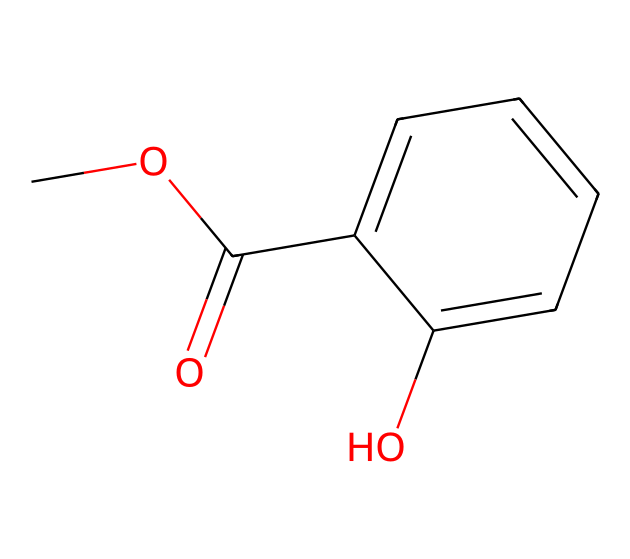What is the molecular formula of methyl salicylate? The SMILES representation shows the structure of methyl salicylate, from which we can derive the molecular formula by counting the atoms. There are 9 carbon atoms (C), 10 hydrogen atoms (H), and 3 oxygen atoms (O) indicated by the structure of the chemical. This gives us a molecular formula of C9H10O3.
Answer: C9H10O3 How many rings are present in the structure of this ester? By examining the structure represented by the SMILES, we can identify the presence of a ring. The part C1=CC=CC=C1 shows a benzene ring, which is a six-membered carbon ring. There are no additional rings present in the structure.
Answer: 1 What functional groups are found in methyl salicylate? The SMILES indicates two functional groups: one is the ester group represented by COC(=O), and the other is the hydroxyl group (–OH) shown at the end of the phenolic part of the structure. These groups contribute to the unique properties of methyl salicylate.
Answer: ester and hydroxyl What type of bond connects the carbon in the ester group to the oxygen atom? The bond connecting the carbon in the ester group to the oxygen atom is a single bond. In the ester part (COC(=O)), C is bonded to O with a single bond, allowing for the ester functionality present in methyl salicylate.
Answer: single bond How many hydrogen atoms are bonded to the aromatic ring? By analyzing the aromatic part of the structure represented by C1=CC=CC=C1, we see that the benzene ring has alternating double bonds, and typically, each carbon in a benzene ring is bonded to one hydrogen. There are five hydrogen atoms bonded to the aromatic ring following this convention.
Answer: 5 